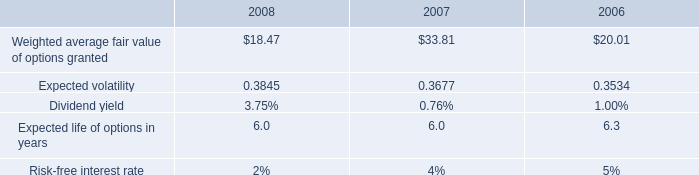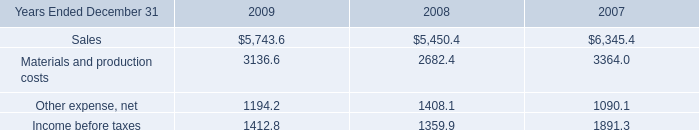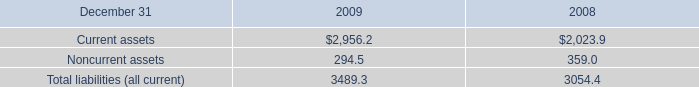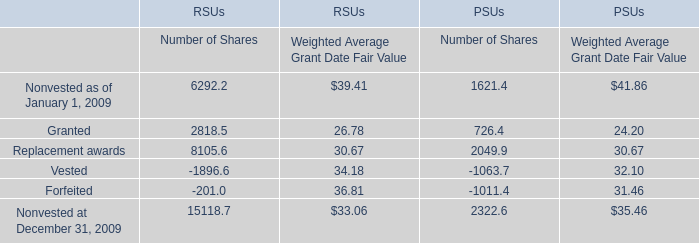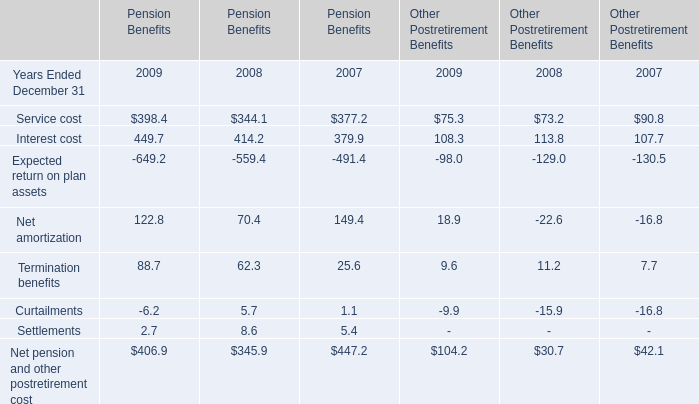What is the total amount of Replacement awards of RSUs Number of Shares, and Income before taxes of 2008 ? 
Computations: (8105.6 + 1359.9)
Answer: 9465.5. 